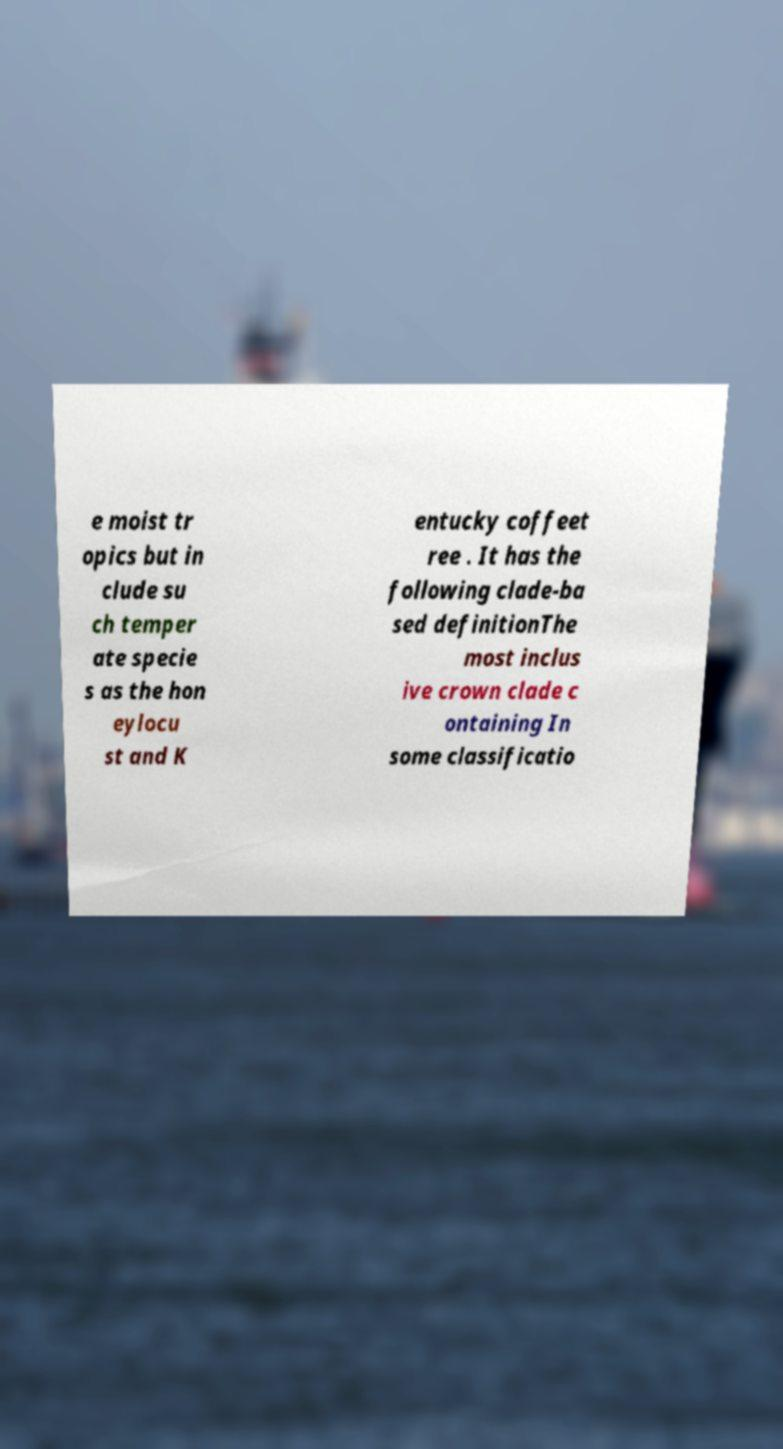Can you accurately transcribe the text from the provided image for me? e moist tr opics but in clude su ch temper ate specie s as the hon eylocu st and K entucky coffeet ree . It has the following clade-ba sed definitionThe most inclus ive crown clade c ontaining In some classificatio 